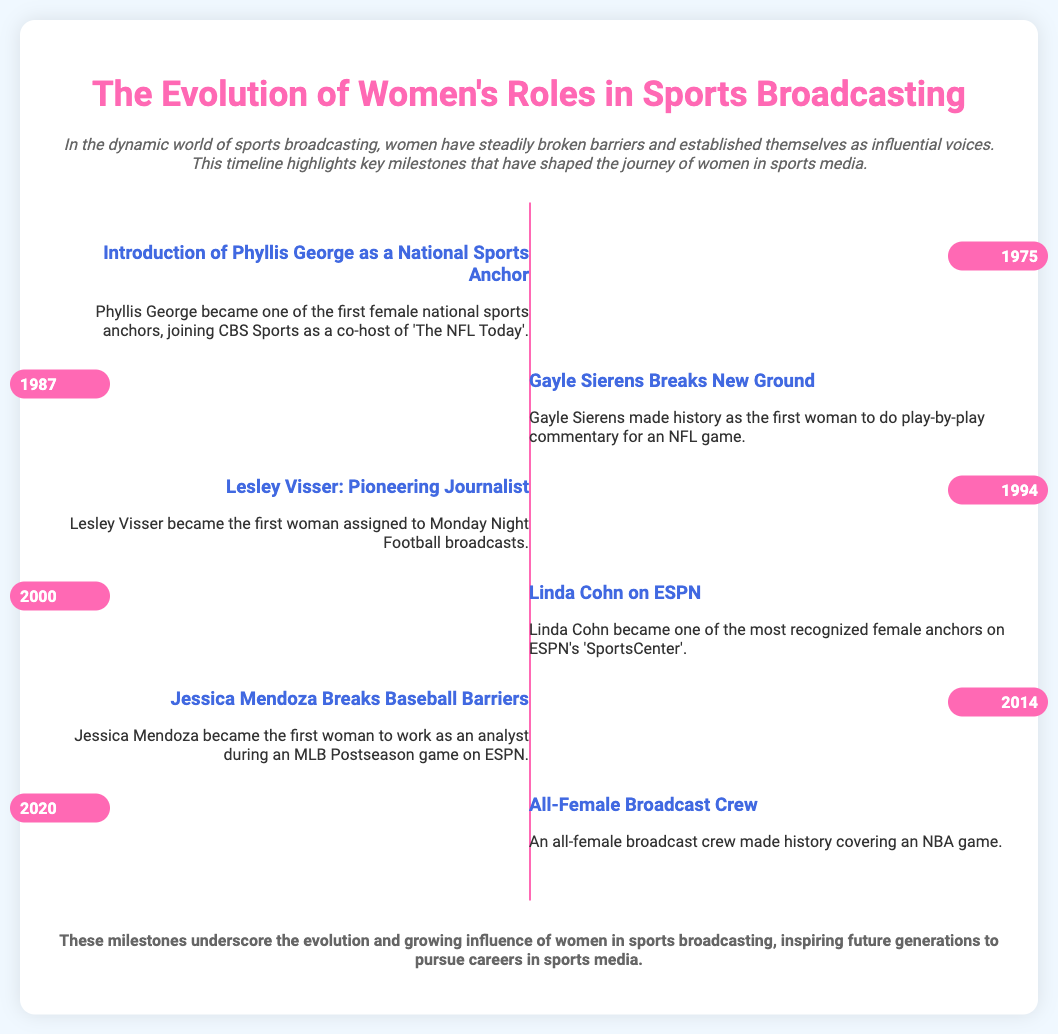what year did Phyllis George become a national sports anchor? Phyllis George became a national sports anchor in 1975, as noted in the milestone.
Answer: 1975 who was the first woman to do play-by-play commentary for an NFL game? The milestone states that Gayle Sierens was the first woman to do play-by-play commentary for an NFL game.
Answer: Gayle Sierens what significant breakthrough did Jessica Mendoza achieve? Jessica Mendoza became the first woman to work as an analyst during an MLB Postseason game, according to the document.
Answer: Analyst during an MLB Postseason game how many years passed between the introduction of Phyllis George and the all-female broadcast crew? The years indicated are 1975 for Phyllis George and 2020 for the all-female broadcast crew, so 2020 - 1975 = 45 years.
Answer: 45 years what role did Lesley Visser take on in 1994? Lesley Visser was assigned to Monday Night Football broadcasts, as mentioned in the milestone.
Answer: Monday Night Football broadcasts what does the timeline illustrate? The timeline illustrates significant milestones that have shaped the journey of women in sports media.
Answer: Significant milestones what was the theme of the presentation? The theme of the presentation revolves around the evolution and growing influence of women in sports broadcasting.
Answer: Evolution of women's roles in sports broadcasting who was recognized as one of the most prominent female anchors on ESPN's SportsCenter? Linda Cohn is recognized as one of the most prominent female anchors on ESPN's SportsCenter.
Answer: Linda Cohn in what year did an all-female broadcast crew cover an NBA game? The document states that an all-female broadcast crew made history covering an NBA game in 2020.
Answer: 2020 